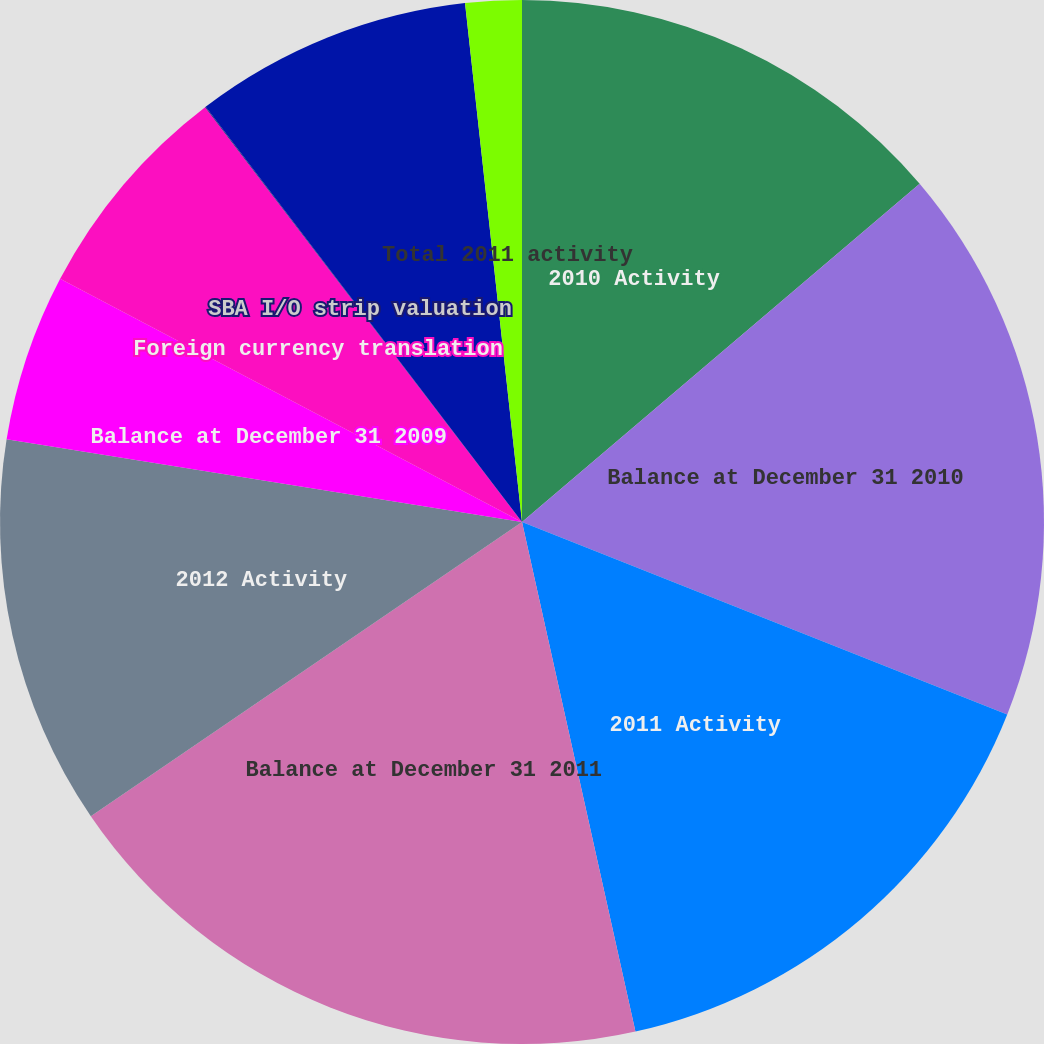Convert chart. <chart><loc_0><loc_0><loc_500><loc_500><pie_chart><fcel>2010 Activity<fcel>Balance at December 31 2010<fcel>2011 Activity<fcel>Balance at December 31 2011<fcel>2012 Activity<fcel>Balance at December 31 2009<fcel>Foreign currency translation<fcel>SBA I/O strip valuation<fcel>Total 2010 activity<fcel>Total 2011 activity<nl><fcel>13.78%<fcel>17.22%<fcel>15.5%<fcel>18.95%<fcel>12.06%<fcel>5.18%<fcel>6.9%<fcel>0.02%<fcel>8.62%<fcel>1.74%<nl></chart> 